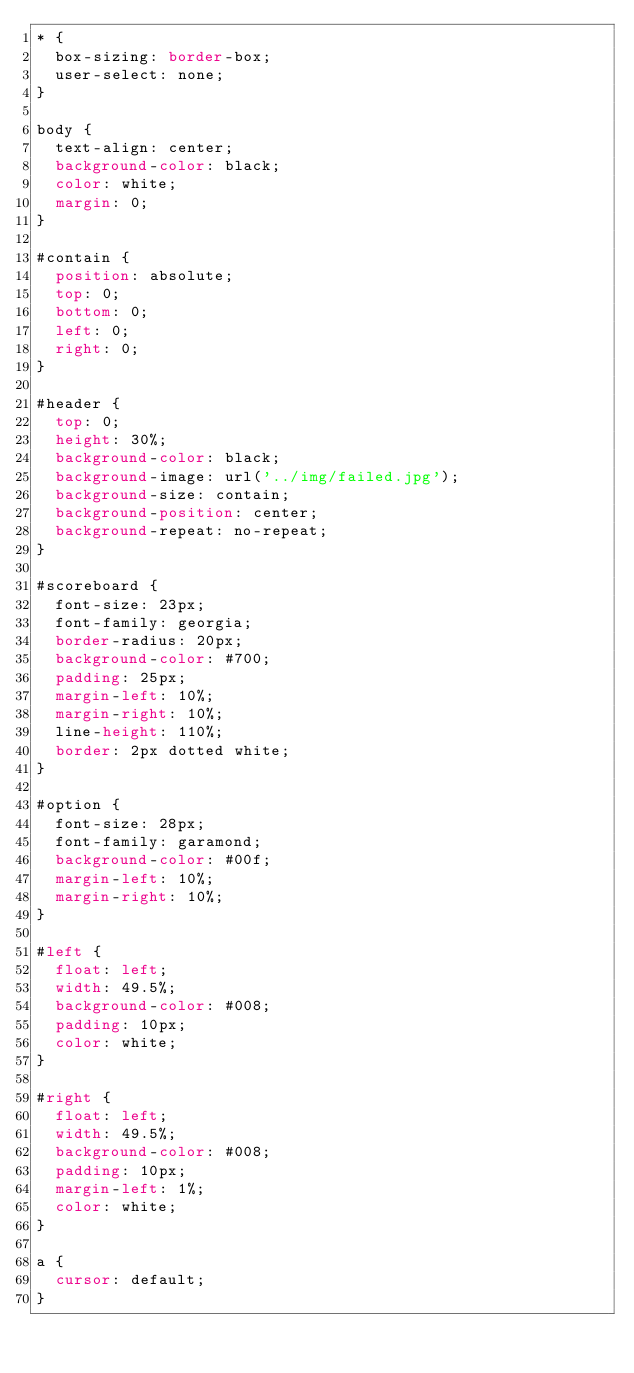<code> <loc_0><loc_0><loc_500><loc_500><_CSS_>* {
	box-sizing: border-box;
	user-select: none;
}

body {
	text-align: center;
	background-color: black;
	color: white;
	margin: 0;
}

#contain {
	position: absolute;
	top: 0;
	bottom: 0;
	left: 0;
	right: 0;
}

#header {
	top: 0;
	height: 30%;
	background-color: black;
	background-image: url('../img/failed.jpg');
	background-size: contain;
	background-position: center;
	background-repeat: no-repeat;
}

#scoreboard {
	font-size: 23px;
	font-family: georgia;
	border-radius: 20px;
	background-color: #700;
	padding: 25px;
	margin-left: 10%;
	margin-right: 10%;
	line-height: 110%;
	border: 2px dotted white;
}

#option {
	font-size: 28px;
	font-family: garamond;
	background-color: #00f;
	margin-left: 10%;
	margin-right: 10%;
}

#left {
	float: left;
	width: 49.5%;
	background-color: #008;
	padding: 10px;
	color: white;
}

#right {
	float: left;
	width: 49.5%;
	background-color: #008;
	padding: 10px;
	margin-left: 1%;
	color: white;
}

a {
	cursor: default;
}</code> 